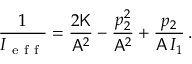<formula> <loc_0><loc_0><loc_500><loc_500>\frac { 1 } { I _ { e f f } } = \frac { 2 K } { A ^ { 2 } } - \frac { p _ { 2 } ^ { 2 } } { A ^ { 2 } } + \frac { p _ { 2 } } { A \, I _ { 1 } } \, .</formula> 